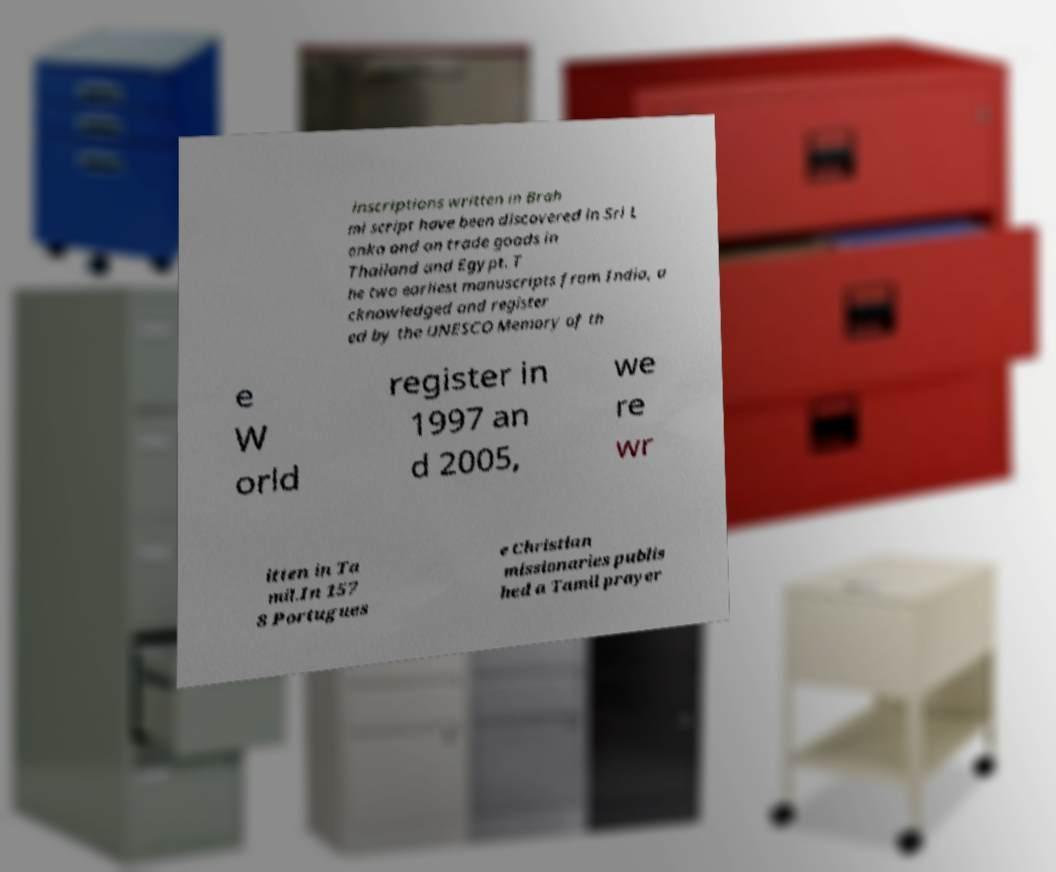For documentation purposes, I need the text within this image transcribed. Could you provide that? inscriptions written in Brah mi script have been discovered in Sri L anka and on trade goods in Thailand and Egypt. T he two earliest manuscripts from India, a cknowledged and register ed by the UNESCO Memory of th e W orld register in 1997 an d 2005, we re wr itten in Ta mil.In 157 8 Portugues e Christian missionaries publis hed a Tamil prayer 